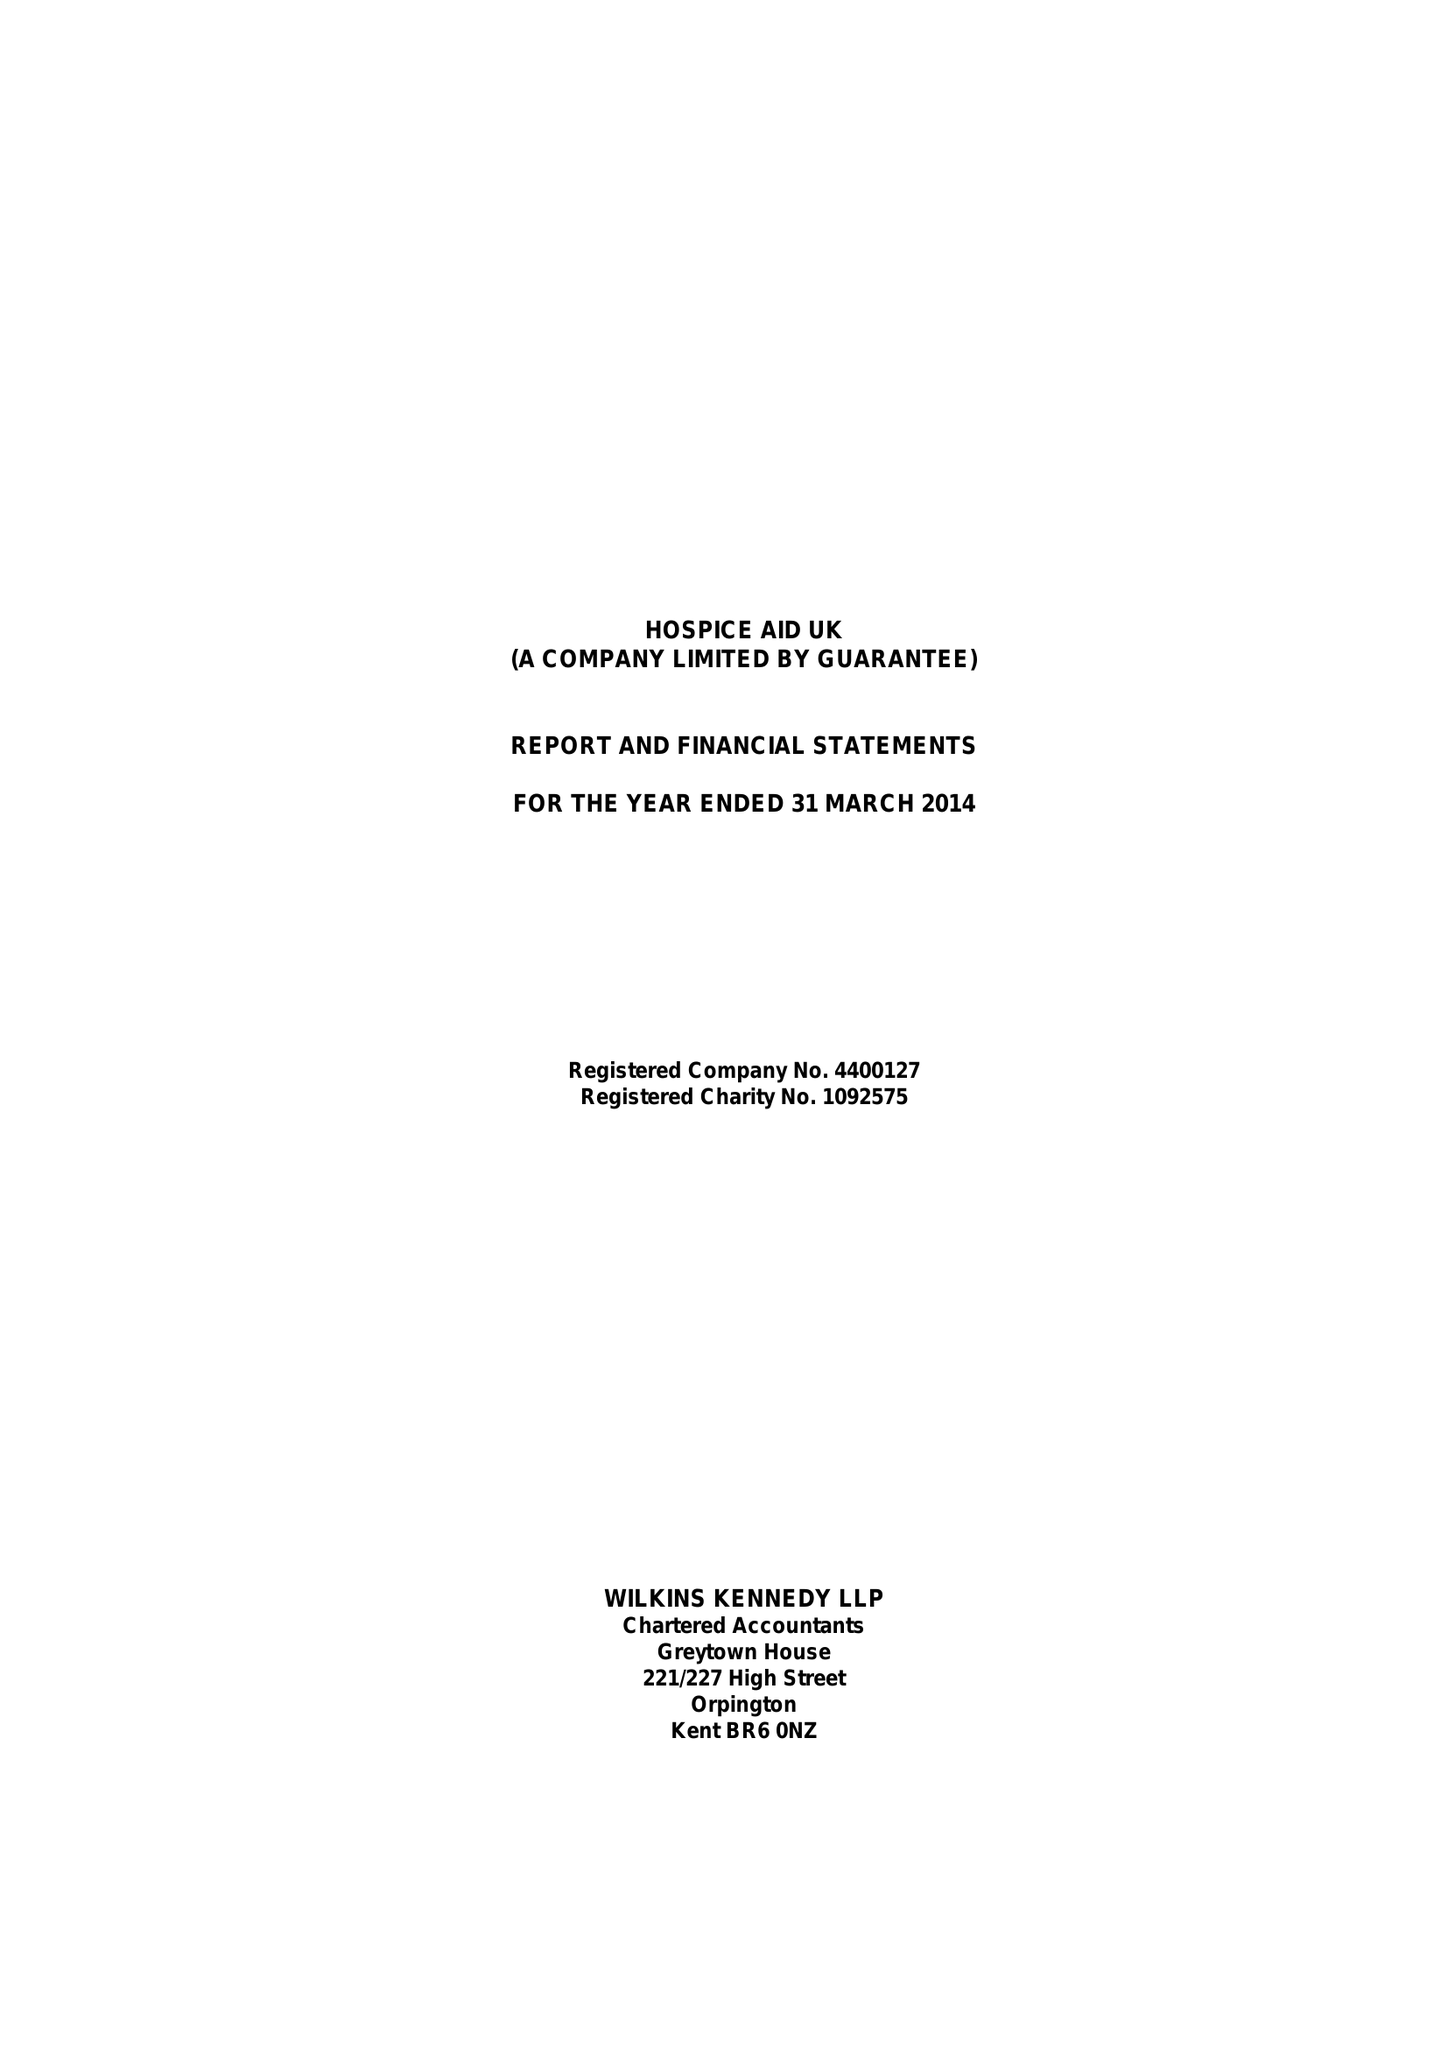What is the value for the charity_number?
Answer the question using a single word or phrase. 1092575 